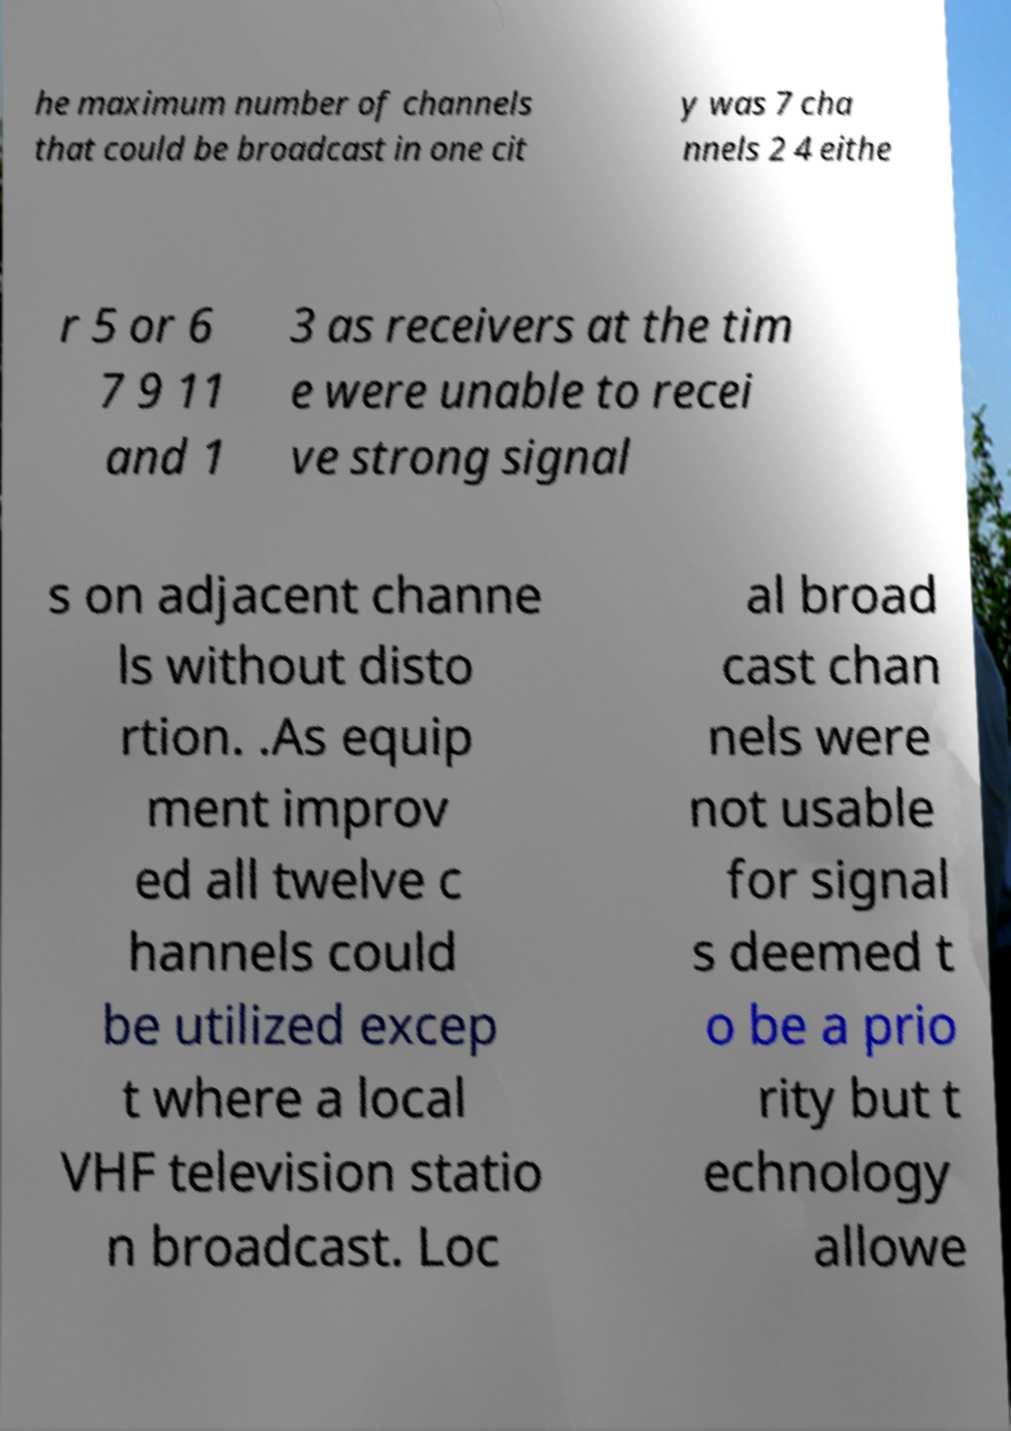What messages or text are displayed in this image? I need them in a readable, typed format. he maximum number of channels that could be broadcast in one cit y was 7 cha nnels 2 4 eithe r 5 or 6 7 9 11 and 1 3 as receivers at the tim e were unable to recei ve strong signal s on adjacent channe ls without disto rtion. .As equip ment improv ed all twelve c hannels could be utilized excep t where a local VHF television statio n broadcast. Loc al broad cast chan nels were not usable for signal s deemed t o be a prio rity but t echnology allowe 